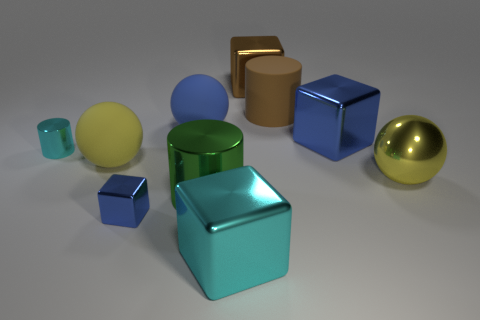Are there any objects that look like they're made out of a different material than the others, and if so, can you describe them? Yes, the two brown objects, one cube and one cylinder, seem to have a matte finish and a different texture from the others. They possibly resemble a material like cardboard or unfinished wood, in contrast to the shiny and smooth appearance of the other objects. 